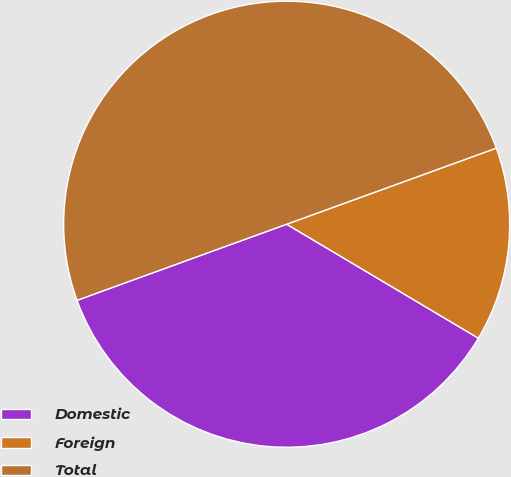Convert chart. <chart><loc_0><loc_0><loc_500><loc_500><pie_chart><fcel>Domestic<fcel>Foreign<fcel>Total<nl><fcel>35.92%<fcel>14.08%<fcel>50.0%<nl></chart> 